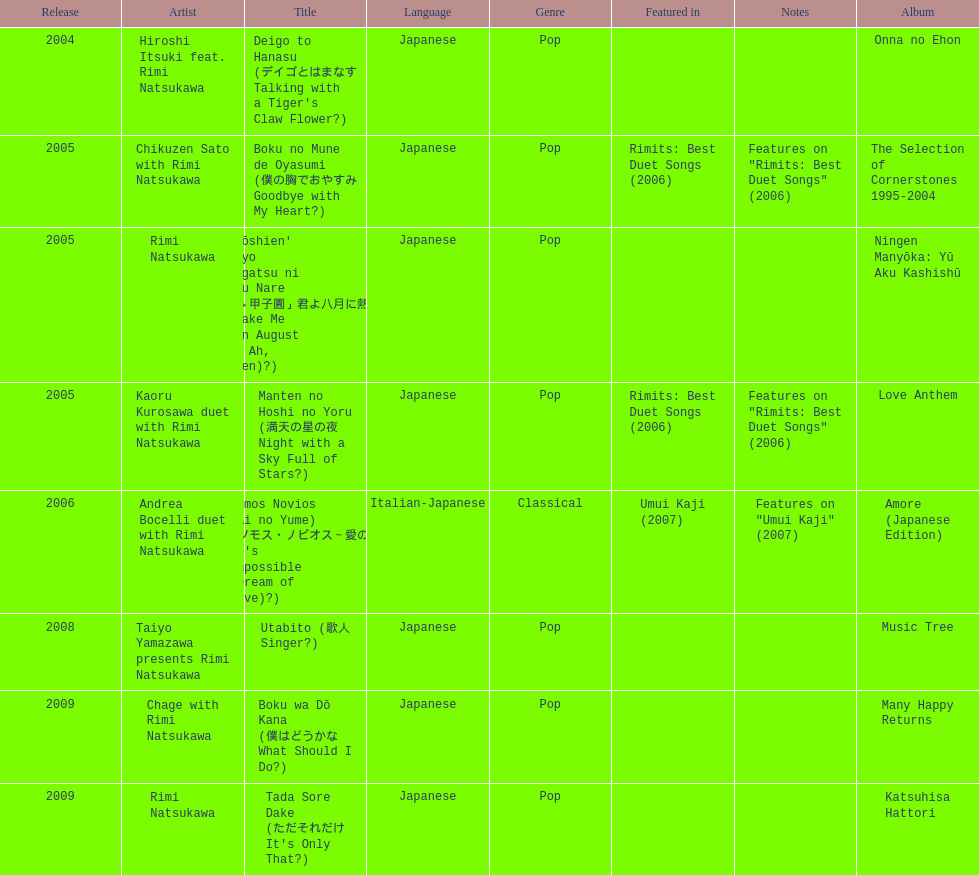Could you help me parse every detail presented in this table? {'header': ['Release', 'Artist', 'Title', 'Language', 'Genre', 'Featured in', 'Notes', 'Album'], 'rows': [['2004', 'Hiroshi Itsuki feat. Rimi Natsukawa', "Deigo to Hanasu (デイゴとはまなす Talking with a Tiger's Claw Flower?)", 'Japanese', 'Pop', '', '', 'Onna no Ehon'], ['2005', 'Chikuzen Sato with Rimi Natsukawa', 'Boku no Mune de Oyasumi (僕の胸でおやすみ Goodbye with My Heart?)', 'Japanese', 'Pop', 'Rimits: Best Duet Songs (2006)', 'Features on "Rimits: Best Duet Songs" (2006)', 'The Selection of Cornerstones 1995-2004'], ['2005', 'Rimi Natsukawa', "'Aa Kōshien' Kimi yo Hachigatsu ni Atsuku Nare (「あゝ甲子園」君よ八月に熱くなれ You Make Me Hot in August (from Ah, Kōshien)?)", 'Japanese', 'Pop', '', '', 'Ningen Manyōka: Yū Aku Kashishū'], ['2005', 'Kaoru Kurosawa duet with Rimi Natsukawa', 'Manten no Hoshi no Yoru (満天の星の夜 Night with a Sky Full of Stars?)', 'Japanese', 'Pop', 'Rimits: Best Duet Songs (2006)', 'Features on "Rimits: Best Duet Songs" (2006)', 'Love Anthem'], ['2006', 'Andrea Bocelli duet with Rimi Natsukawa', "Somos Novios (Ai no Yume) (ソモス・ノビオス～愛の夢 It's Impossible (Dream of Love)?)", 'Italian-Japanese', 'Classical', 'Umui Kaji (2007)', 'Features on "Umui Kaji" (2007)', 'Amore (Japanese Edition)'], ['2008', 'Taiyo Yamazawa presents Rimi Natsukawa', 'Utabito (歌人 Singer?)', 'Japanese', 'Pop', '', '', 'Music Tree'], ['2009', 'Chage with Rimi Natsukawa', 'Boku wa Dō Kana (僕はどうかな What Should I Do?)', 'Japanese', 'Pop', '', '', 'Many Happy Returns'], ['2009', 'Rimi Natsukawa', "Tada Sore Dake (ただそれだけ It's Only That?)", 'Japanese', 'Pop', '', '', 'Katsuhisa Hattori']]} Which year had the most titles released? 2005. 